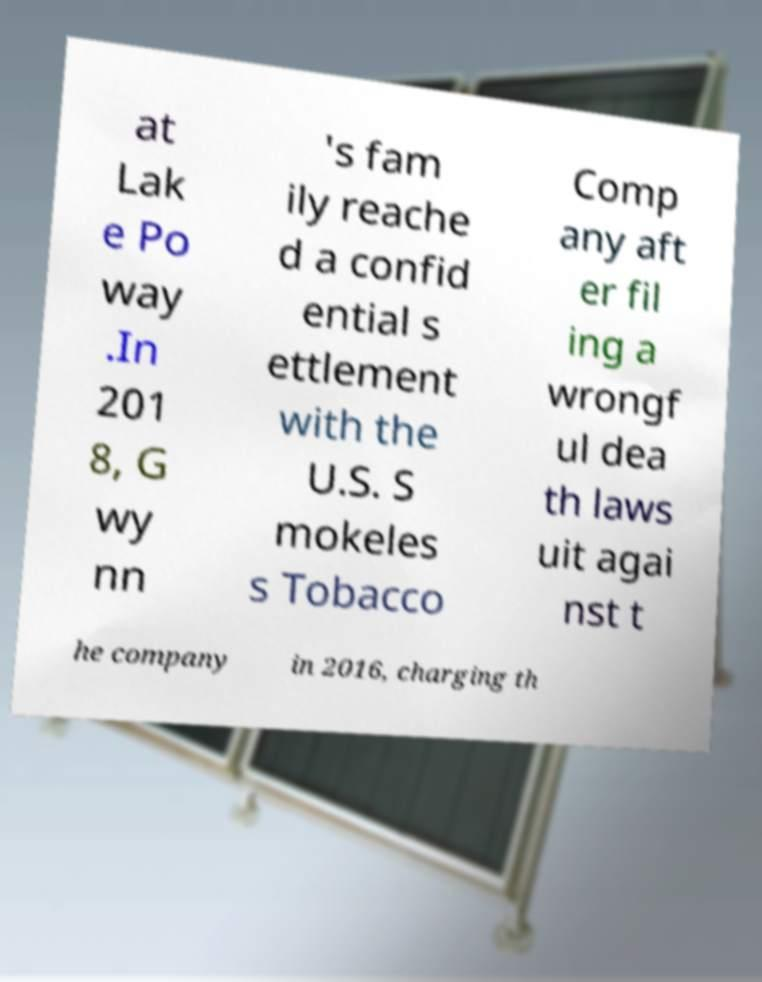Please read and relay the text visible in this image. What does it say? at Lak e Po way .In 201 8, G wy nn 's fam ily reache d a confid ential s ettlement with the U.S. S mokeles s Tobacco Comp any aft er fil ing a wrongf ul dea th laws uit agai nst t he company in 2016, charging th 